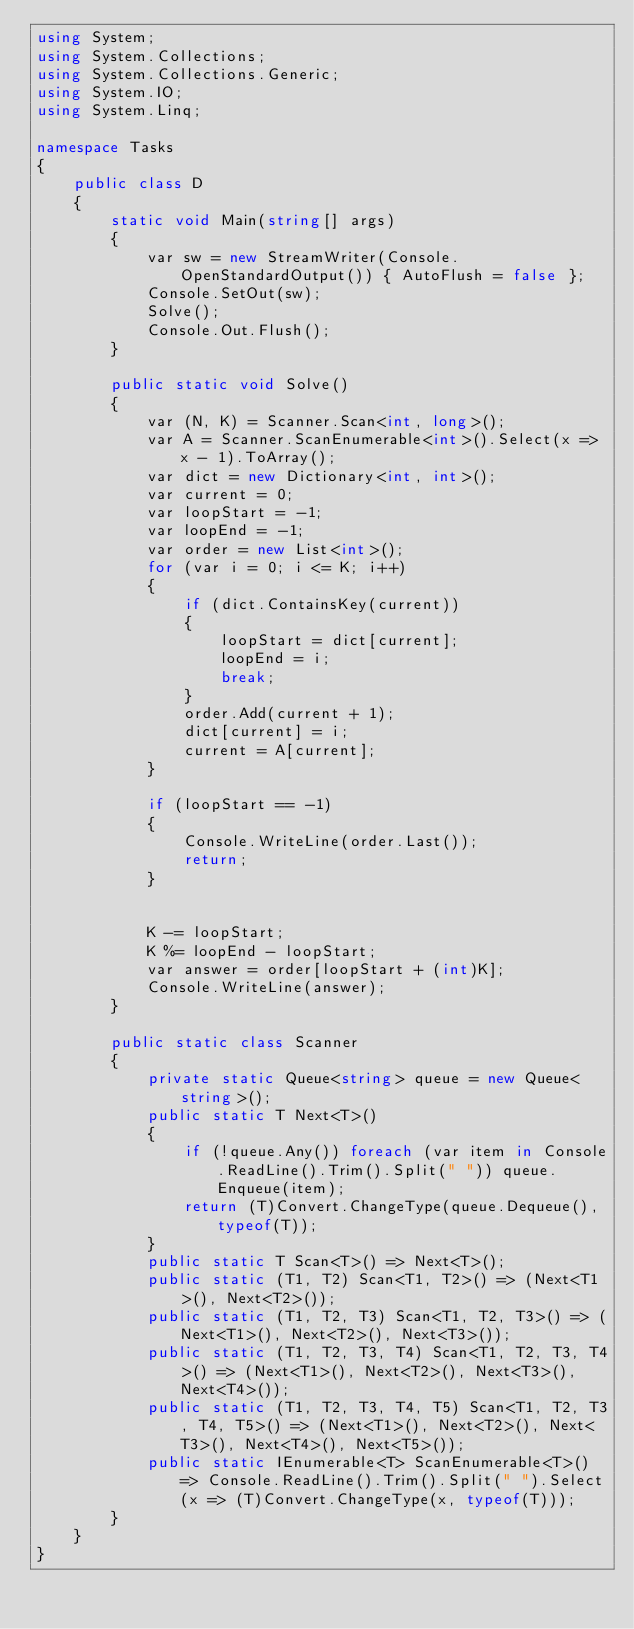Convert code to text. <code><loc_0><loc_0><loc_500><loc_500><_C#_>using System;
using System.Collections;
using System.Collections.Generic;
using System.IO;
using System.Linq;

namespace Tasks
{
    public class D
    {
        static void Main(string[] args)
        {
            var sw = new StreamWriter(Console.OpenStandardOutput()) { AutoFlush = false };
            Console.SetOut(sw);
            Solve();
            Console.Out.Flush();
        }

        public static void Solve()
        {
            var (N, K) = Scanner.Scan<int, long>();
            var A = Scanner.ScanEnumerable<int>().Select(x => x - 1).ToArray();
            var dict = new Dictionary<int, int>();
            var current = 0;
            var loopStart = -1;
            var loopEnd = -1;
            var order = new List<int>();
            for (var i = 0; i <= K; i++)
            {
                if (dict.ContainsKey(current))
                {
                    loopStart = dict[current];
                    loopEnd = i;
                    break;
                }
                order.Add(current + 1);
                dict[current] = i;
                current = A[current];
            }

            if (loopStart == -1)
            {
                Console.WriteLine(order.Last());
                return;
            }


            K -= loopStart;
            K %= loopEnd - loopStart;
            var answer = order[loopStart + (int)K];
            Console.WriteLine(answer);
        }

        public static class Scanner
        {
            private static Queue<string> queue = new Queue<string>();
            public static T Next<T>()
            {
                if (!queue.Any()) foreach (var item in Console.ReadLine().Trim().Split(" ")) queue.Enqueue(item);
                return (T)Convert.ChangeType(queue.Dequeue(), typeof(T));
            }
            public static T Scan<T>() => Next<T>();
            public static (T1, T2) Scan<T1, T2>() => (Next<T1>(), Next<T2>());
            public static (T1, T2, T3) Scan<T1, T2, T3>() => (Next<T1>(), Next<T2>(), Next<T3>());
            public static (T1, T2, T3, T4) Scan<T1, T2, T3, T4>() => (Next<T1>(), Next<T2>(), Next<T3>(), Next<T4>());
            public static (T1, T2, T3, T4, T5) Scan<T1, T2, T3, T4, T5>() => (Next<T1>(), Next<T2>(), Next<T3>(), Next<T4>(), Next<T5>());
            public static IEnumerable<T> ScanEnumerable<T>() => Console.ReadLine().Trim().Split(" ").Select(x => (T)Convert.ChangeType(x, typeof(T)));
        }
    }
}
</code> 